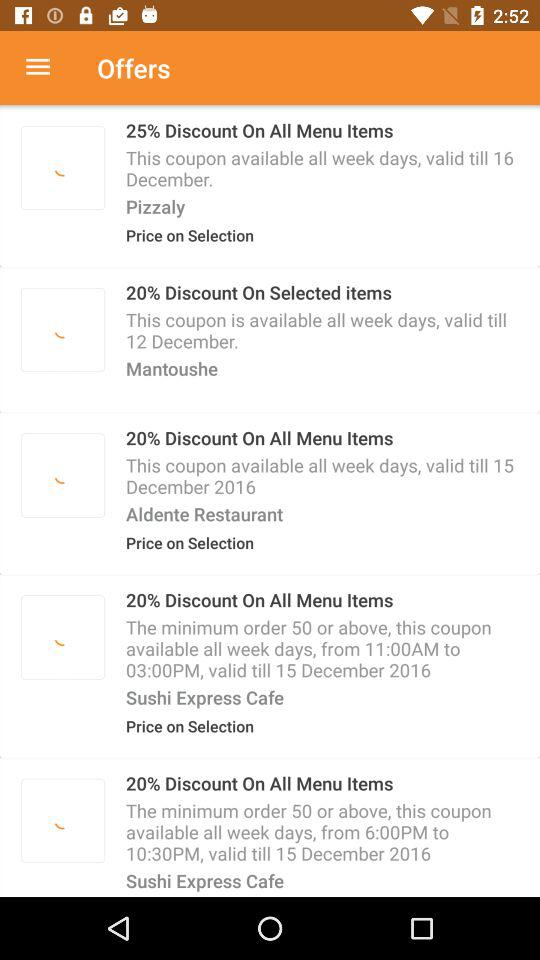What is the valid date for discounted offers on Pizzaly? The valid date for discounted offers on Pizzaly is December 16. 